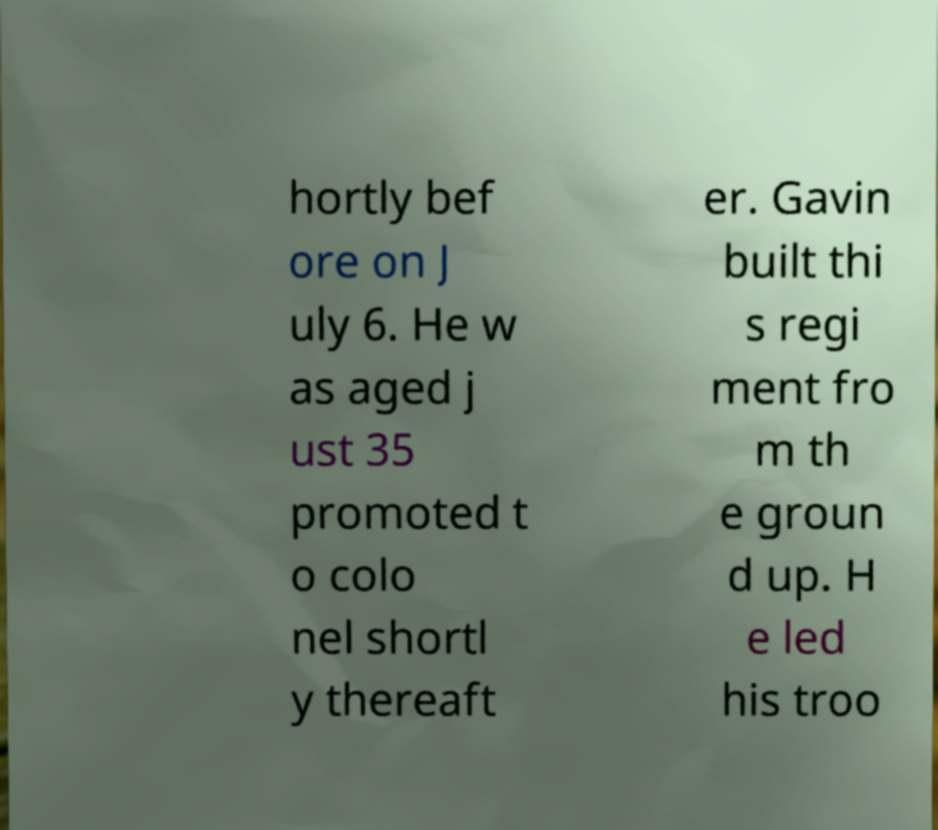Could you extract and type out the text from this image? hortly bef ore on J uly 6. He w as aged j ust 35 promoted t o colo nel shortl y thereaft er. Gavin built thi s regi ment fro m th e groun d up. H e led his troo 